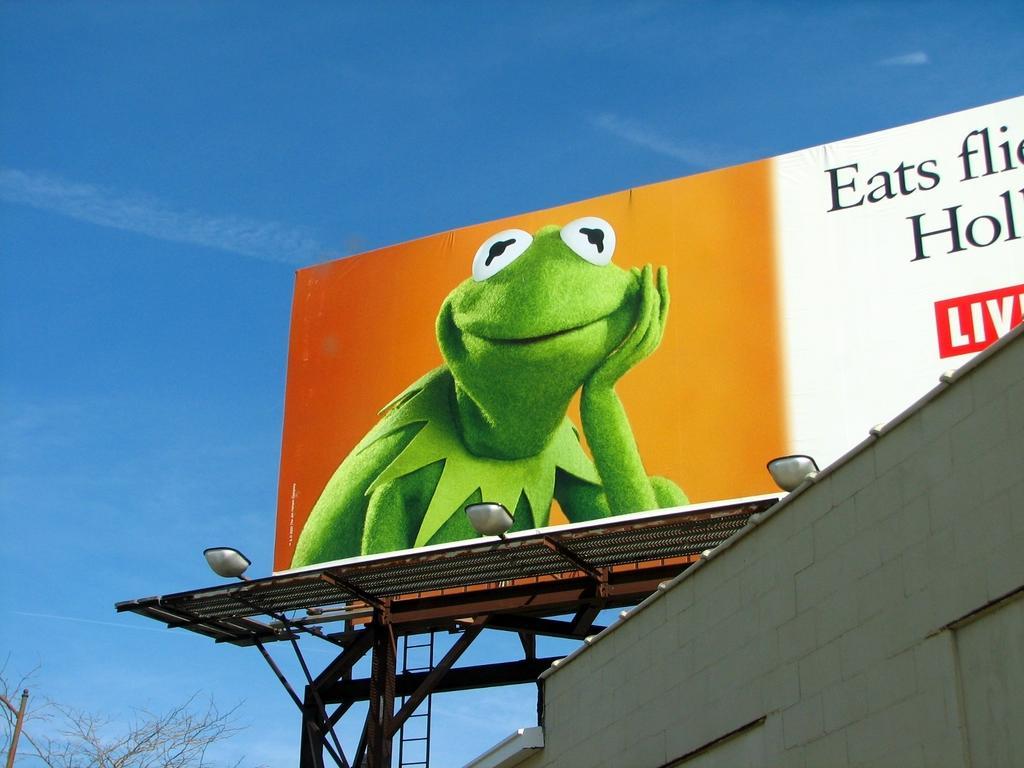Can you describe this image briefly? In the foreground, I can see a building, lights, metal rods, trees and a hoarding. In the background, I can see the blue sky. This image is taken, maybe during a day. 